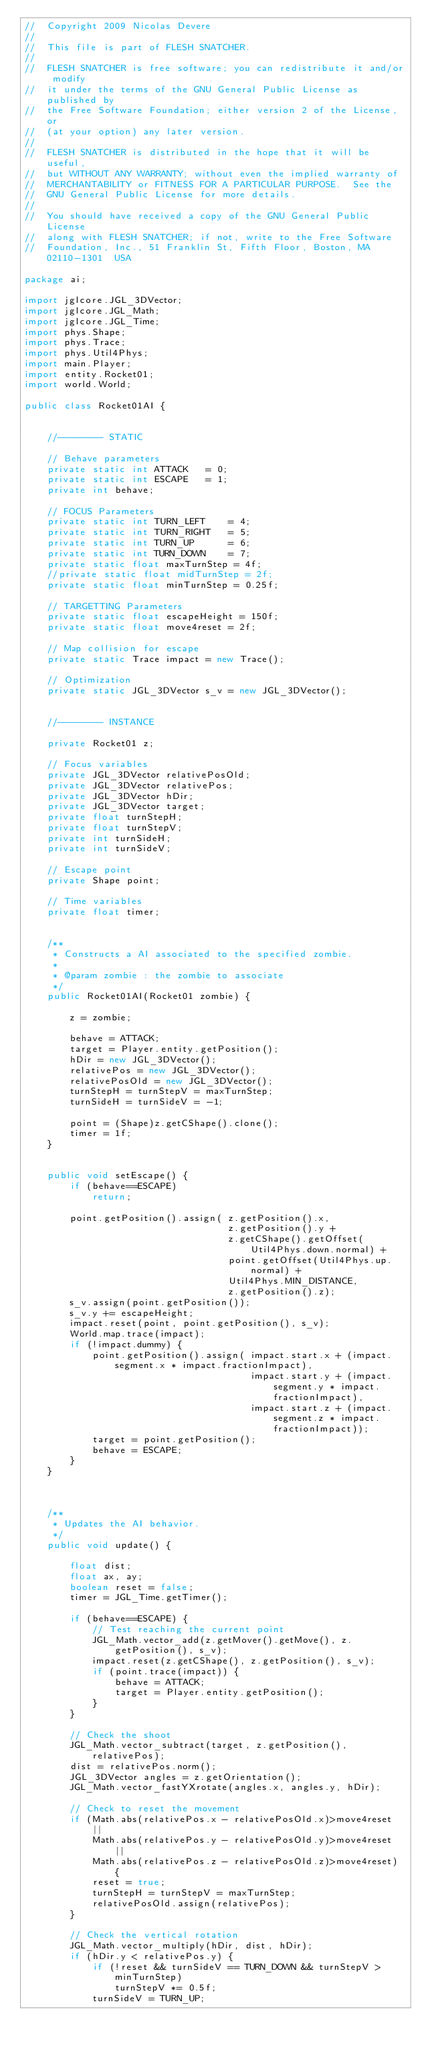<code> <loc_0><loc_0><loc_500><loc_500><_Java_>//	Copyright 2009 Nicolas Devere
//
//	This file is part of FLESH SNATCHER.
//
//	FLESH SNATCHER is free software; you can redistribute it and/or modify
//	it under the terms of the GNU General Public License as published by
//	the Free Software Foundation; either version 2 of the License, or
//	(at your option) any later version.
//
//	FLESH SNATCHER is distributed in the hope that it will be useful,
//	but WITHOUT ANY WARRANTY; without even the implied warranty of
//	MERCHANTABILITY or FITNESS FOR A PARTICULAR PURPOSE.  See the
//	GNU General Public License for more details.
//
//	You should have received a copy of the GNU General Public License
//	along with FLESH SNATCHER; if not, write to the Free Software
//	Foundation, Inc., 51 Franklin St, Fifth Floor, Boston, MA  02110-1301  USA

package ai;

import jglcore.JGL_3DVector;
import jglcore.JGL_Math;
import jglcore.JGL_Time;
import phys.Shape;
import phys.Trace;
import phys.Util4Phys;
import main.Player;
import entity.Rocket01;
import world.World;

public class Rocket01AI {
	

	//-------- STATIC
	
	// Behave parameters
	private static int ATTACK 	= 0;
	private static int ESCAPE 	= 1;
	private int behave;
	
	// FOCUS Parameters
	private static int TURN_LEFT 	= 4;
	private static int TURN_RIGHT 	= 5;
	private static int TURN_UP 		= 6;
	private static int TURN_DOWN 	= 7;
	private static float maxTurnStep = 4f;
	//private static float midTurnStep = 2f;
	private static float minTurnStep = 0.25f;
	
	// TARGETTING Parameters
	private static float escapeHeight = 150f;
	private static float move4reset = 2f;
	
	// Map collision for escape
	private static Trace impact = new Trace();
	
	// Optimization
	private static JGL_3DVector s_v = new JGL_3DVector();
	
	
	//-------- INSTANCE
	
	private Rocket01 z;
	
	// Focus variables
	private JGL_3DVector relativePosOld;
	private JGL_3DVector relativePos;
	private JGL_3DVector hDir;
	private JGL_3DVector target;
	private float turnStepH;
	private float turnStepV;
	private int turnSideH;
	private int turnSideV;
	
	// Escape point
	private Shape point;
	
	// Time variables
	private float timer;
	
	
	/**
	 * Constructs a AI associated to the specified zombie.
	 * 
	 * @param zombie : the zombie to associate
	 */
	public Rocket01AI(Rocket01 zombie) {
		
		z = zombie;
		
		behave = ATTACK;
		target = Player.entity.getPosition();
		hDir = new JGL_3DVector();
		relativePos = new JGL_3DVector();
		relativePosOld = new JGL_3DVector();
		turnStepH = turnStepV = maxTurnStep;
		turnSideH = turnSideV = -1;
		
		point = (Shape)z.getCShape().clone();
		timer = 1f;
	}
	
	
	public void setEscape() {
		if (behave==ESCAPE)
			return;
		
		point.getPosition().assign(	z.getPosition().x, 
									z.getPosition().y + 
									z.getCShape().getOffset(Util4Phys.down.normal) + 
									point.getOffset(Util4Phys.up.normal) + 
									Util4Phys.MIN_DISTANCE, 
									z.getPosition().z);
		s_v.assign(point.getPosition());
		s_v.y += escapeHeight;
		impact.reset(point, point.getPosition(), s_v);
		World.map.trace(impact);
		if (!impact.dummy) {
			point.getPosition().assign(	impact.start.x + (impact.segment.x * impact.fractionImpact), 
										impact.start.y + (impact.segment.y * impact.fractionImpact), 
										impact.start.z + (impact.segment.z * impact.fractionImpact));
			target = point.getPosition();
			behave = ESCAPE;
		}
	}
	
	
	
	/**
	 * Updates the AI behavior.
	 */
	public void update() {
		
		float dist;
		float ax, ay;
		boolean reset = false;
		timer = JGL_Time.getTimer();
		
		if (behave==ESCAPE) {
			// Test reaching the current point
			JGL_Math.vector_add(z.getMover().getMove(), z.getPosition(), s_v);
			impact.reset(z.getCShape(), z.getPosition(), s_v);
			if (point.trace(impact)) {
				behave = ATTACK;
				target = Player.entity.getPosition();
			}
		}
		
		// Check the shoot
		JGL_Math.vector_subtract(target, z.getPosition(), relativePos);
		dist = relativePos.norm();
		JGL_3DVector angles = z.getOrientation();
		JGL_Math.vector_fastYXrotate(angles.x, angles.y, hDir);
		
		// Check to reset the movement
		if (Math.abs(relativePos.x - relativePosOld.x)>move4reset || 
			Math.abs(relativePos.y - relativePosOld.y)>move4reset || 
			Math.abs(relativePos.z - relativePosOld.z)>move4reset) {
			reset = true;
			turnStepH = turnStepV = maxTurnStep;
			relativePosOld.assign(relativePos);
		}
		
		// Check the vertical rotation
		JGL_Math.vector_multiply(hDir, dist, hDir);
		if (hDir.y < relativePos.y) {
			if (!reset && turnSideV == TURN_DOWN && turnStepV > minTurnStep)
				turnStepV *= 0.5f;
			turnSideV = TURN_UP;</code> 